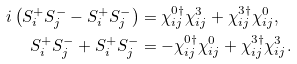Convert formula to latex. <formula><loc_0><loc_0><loc_500><loc_500>i \left ( S _ { i } ^ { + } S _ { j } ^ { - } - S _ { i } ^ { + } S _ { j } ^ { - } \right ) & = \chi ^ { 0 \dagger } _ { i j } \chi ^ { 3 } _ { i j } + \chi ^ { 3 \dagger } _ { i j } \chi ^ { 0 } _ { i j } , \\ S _ { i } ^ { + } S _ { j } ^ { - } + S _ { i } ^ { + } S _ { j } ^ { - } & = - \chi ^ { 0 \dagger } _ { i j } \chi ^ { 0 } _ { i j } + \chi ^ { 3 \dagger } _ { i j } \chi ^ { 3 } _ { i j } .</formula> 